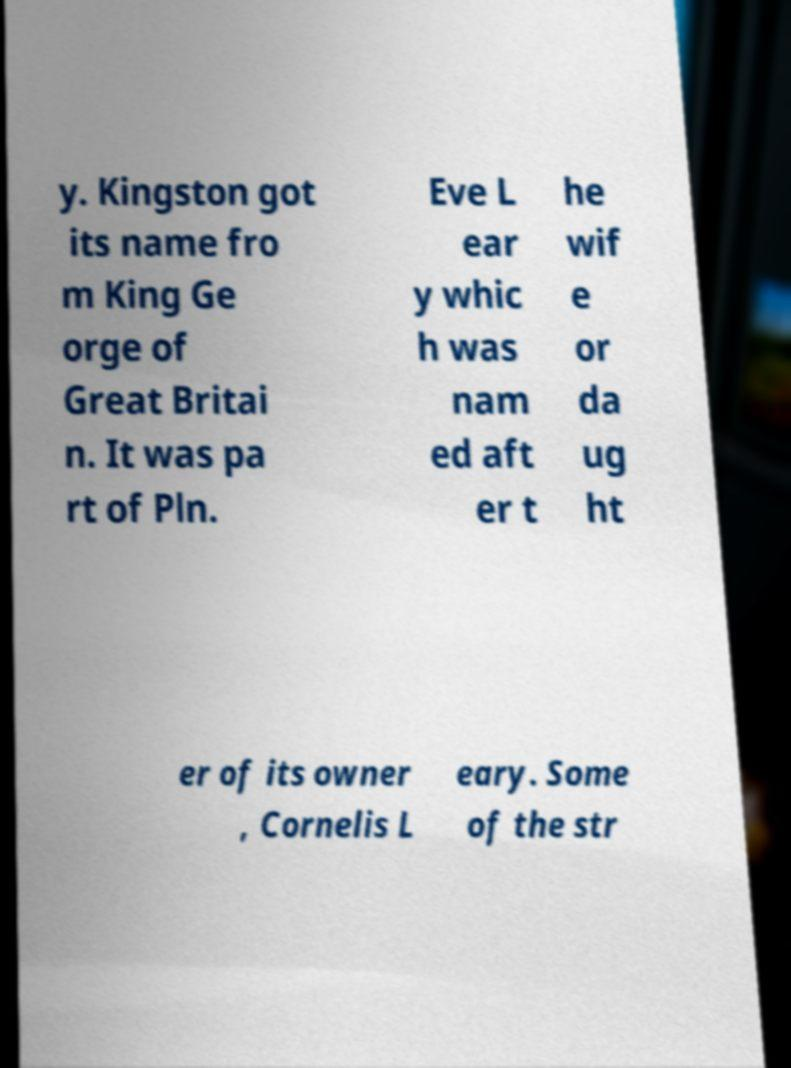What messages or text are displayed in this image? I need them in a readable, typed format. y. Kingston got its name fro m King Ge orge of Great Britai n. It was pa rt of Pln. Eve L ear y whic h was nam ed aft er t he wif e or da ug ht er of its owner , Cornelis L eary. Some of the str 